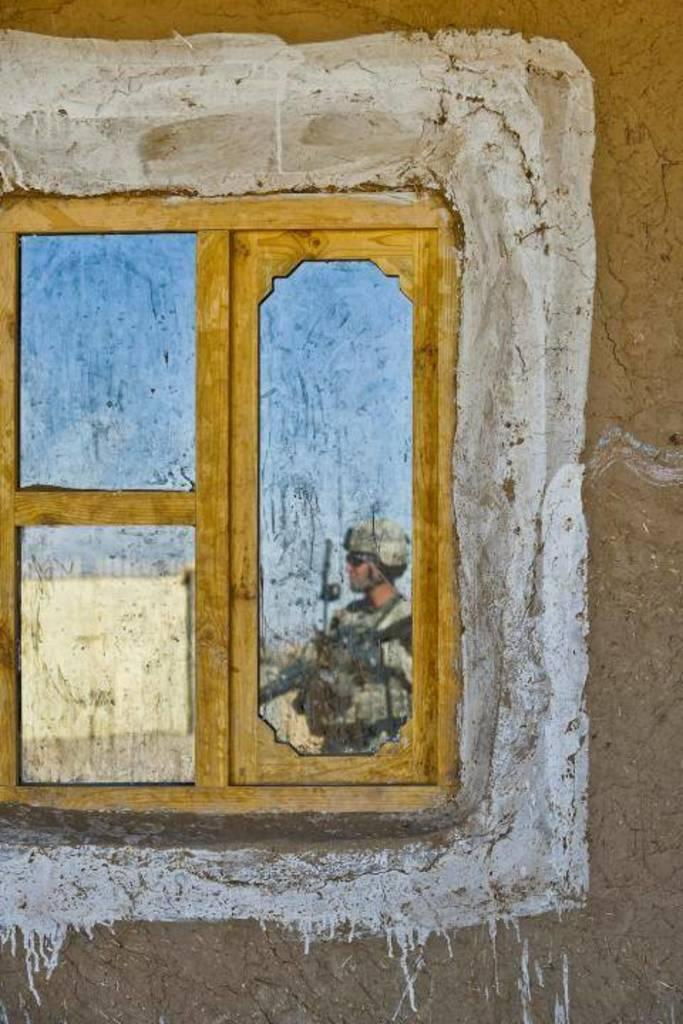What is present on the wall in the image? There is a window on the wall in the image. What can be seen in the window? There is a reflection of a person, a house, and the sky in the window. Can you describe the reflection of the sky in the window? The reflection of the sky in the window shows the sky's appearance. How many roses can be seen growing in the window? There are no roses visible in the window; the reflections show a person, a house, and the sky. What type of plants are growing in the hole in the window? There is no hole or plants visible in the window; it only shows reflections of the person, the house, and the sky. 